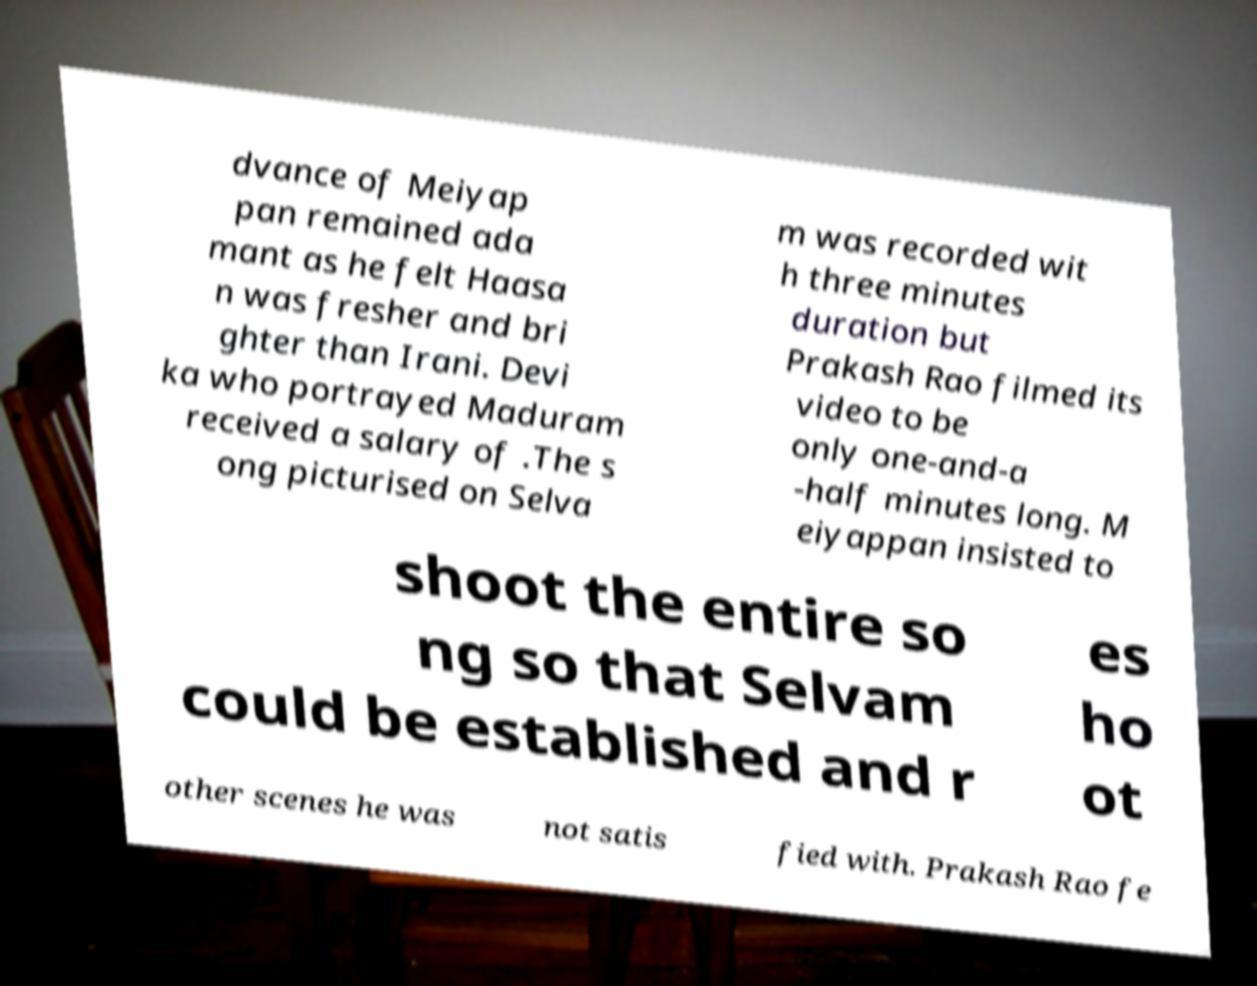There's text embedded in this image that I need extracted. Can you transcribe it verbatim? dvance of Meiyap pan remained ada mant as he felt Haasa n was fresher and bri ghter than Irani. Devi ka who portrayed Maduram received a salary of .The s ong picturised on Selva m was recorded wit h three minutes duration but Prakash Rao filmed its video to be only one-and-a -half minutes long. M eiyappan insisted to shoot the entire so ng so that Selvam could be established and r es ho ot other scenes he was not satis fied with. Prakash Rao fe 